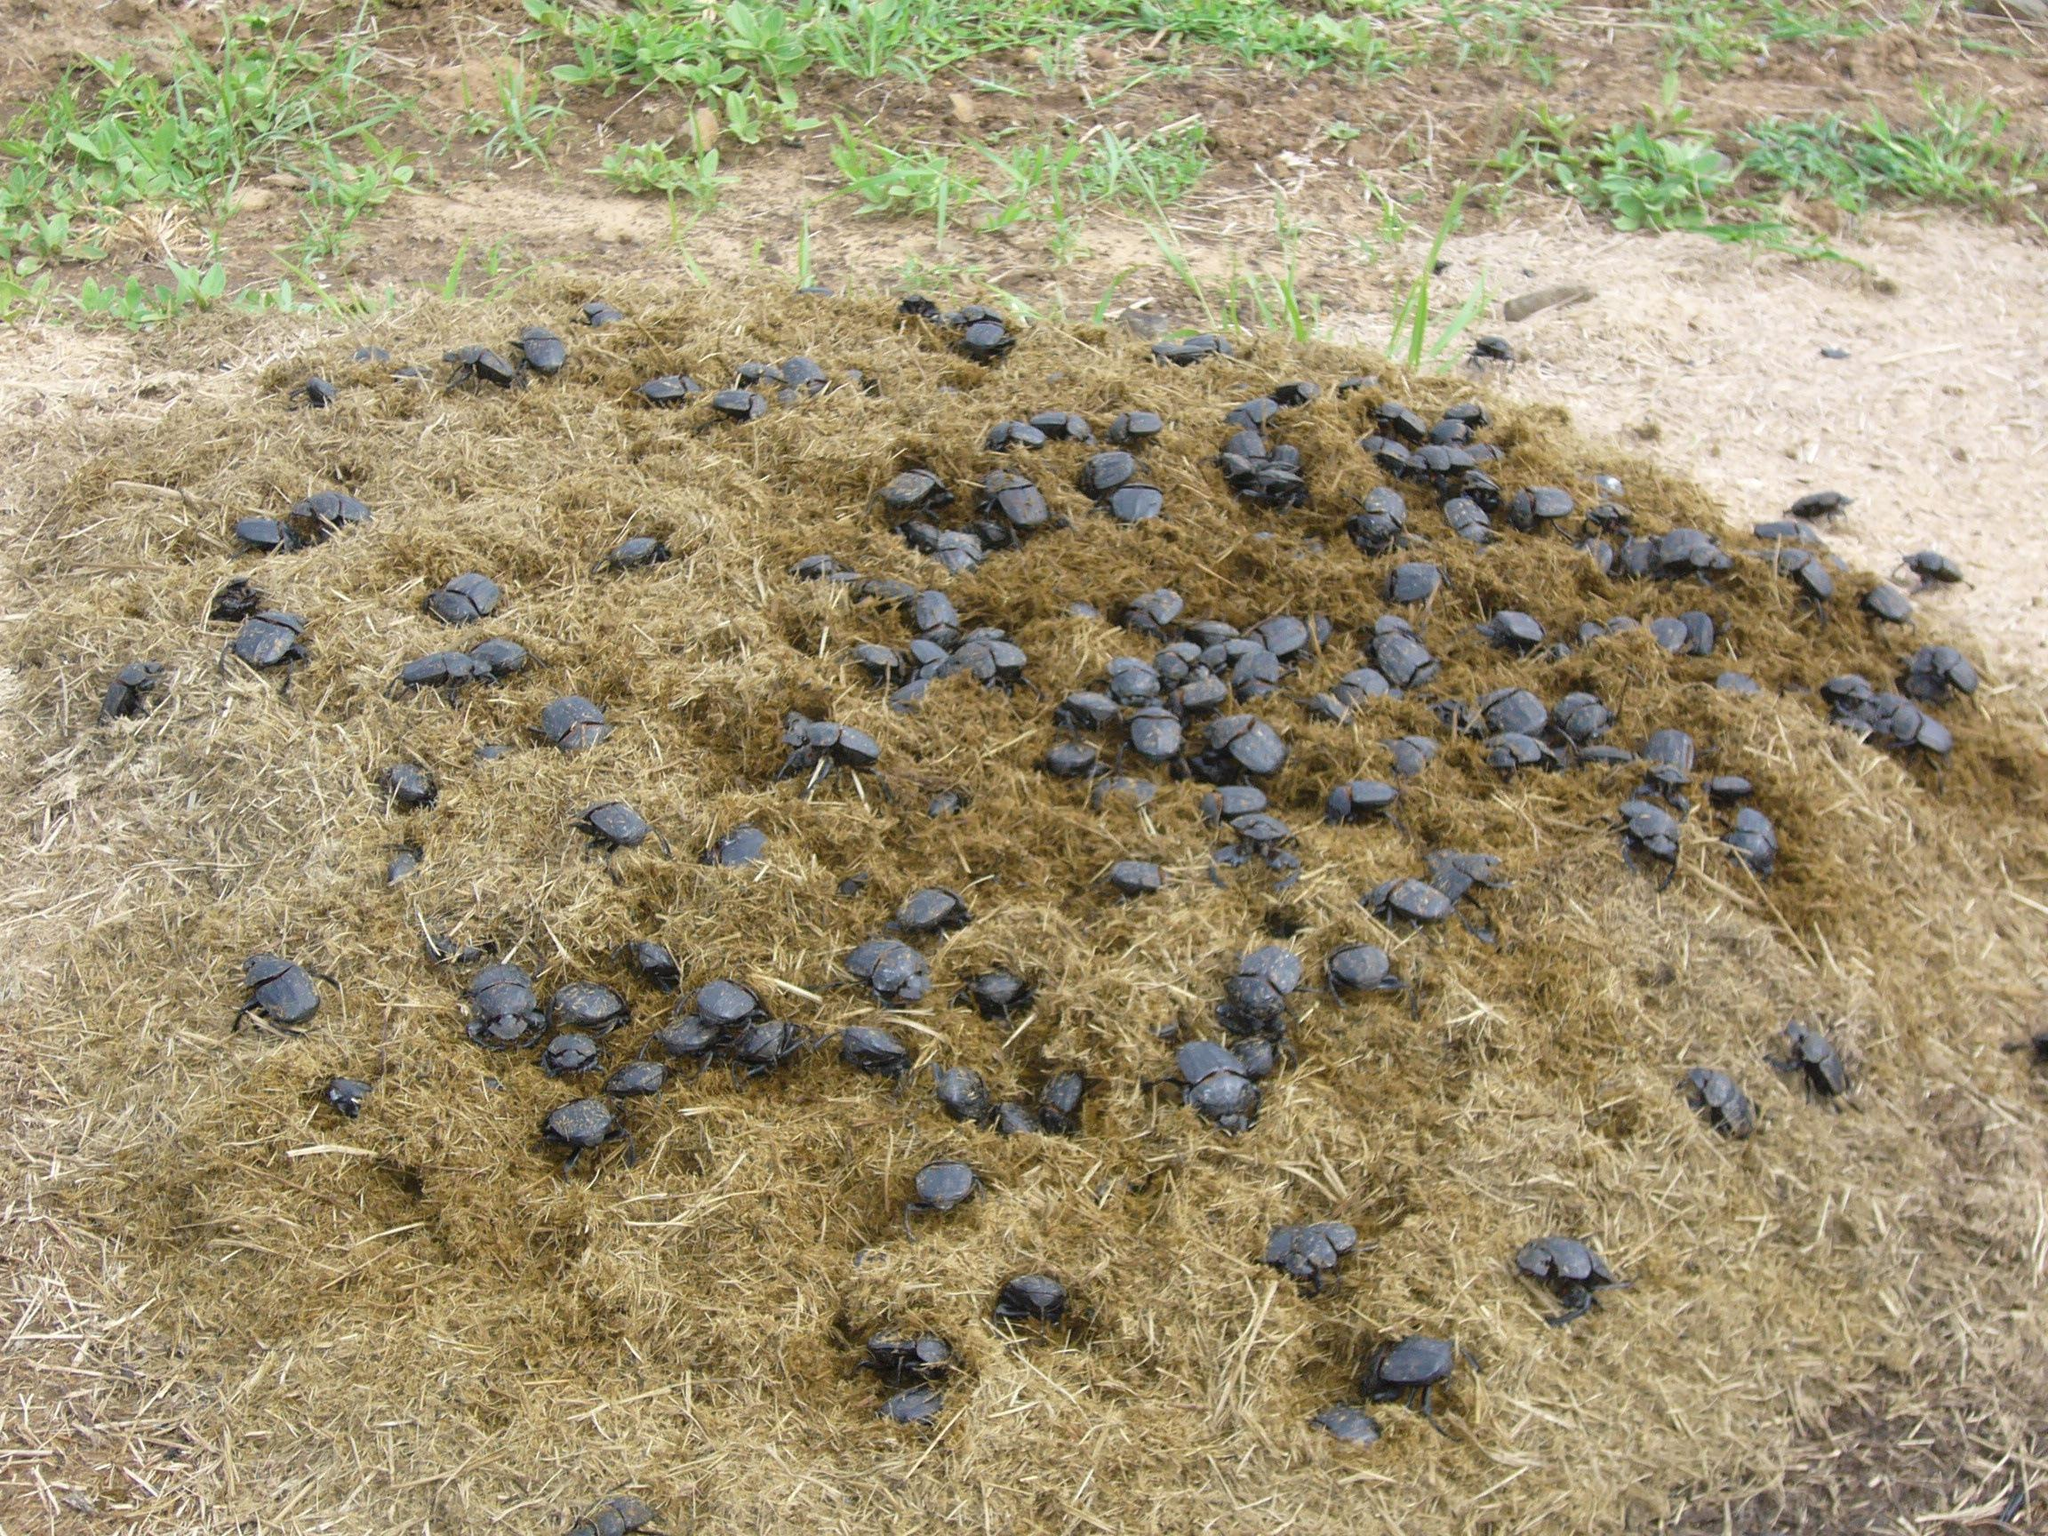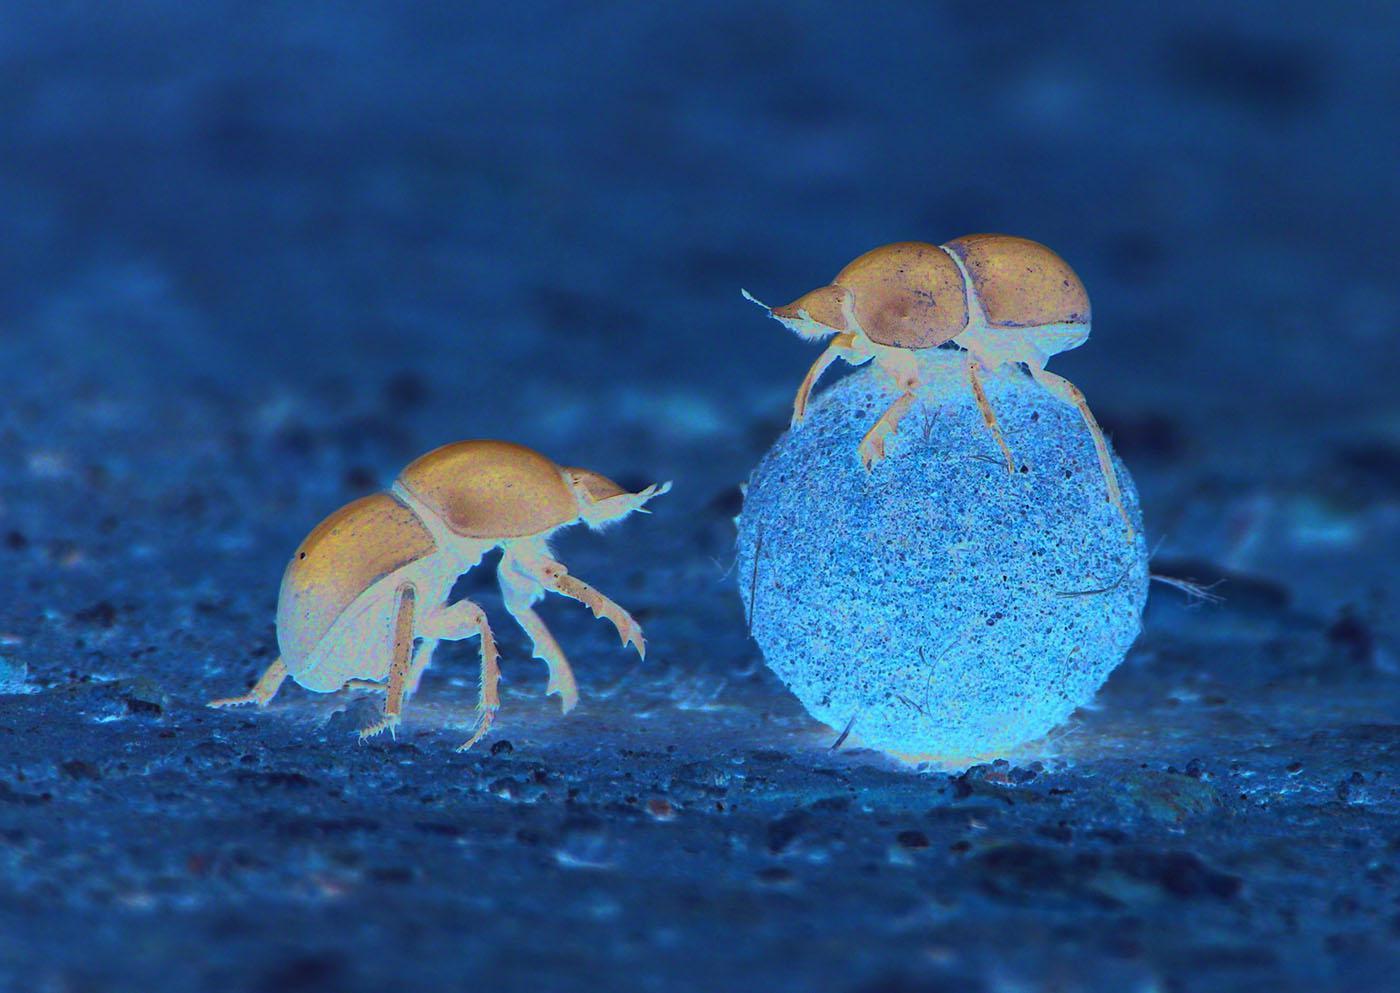The first image is the image on the left, the second image is the image on the right. Analyze the images presented: Is the assertion "One image has more than 20 dung beetles." valid? Answer yes or no. Yes. The first image is the image on the left, the second image is the image on the right. Considering the images on both sides, is "There are two dung beetles working on one ball of dung in natural lighting." valid? Answer yes or no. No. 